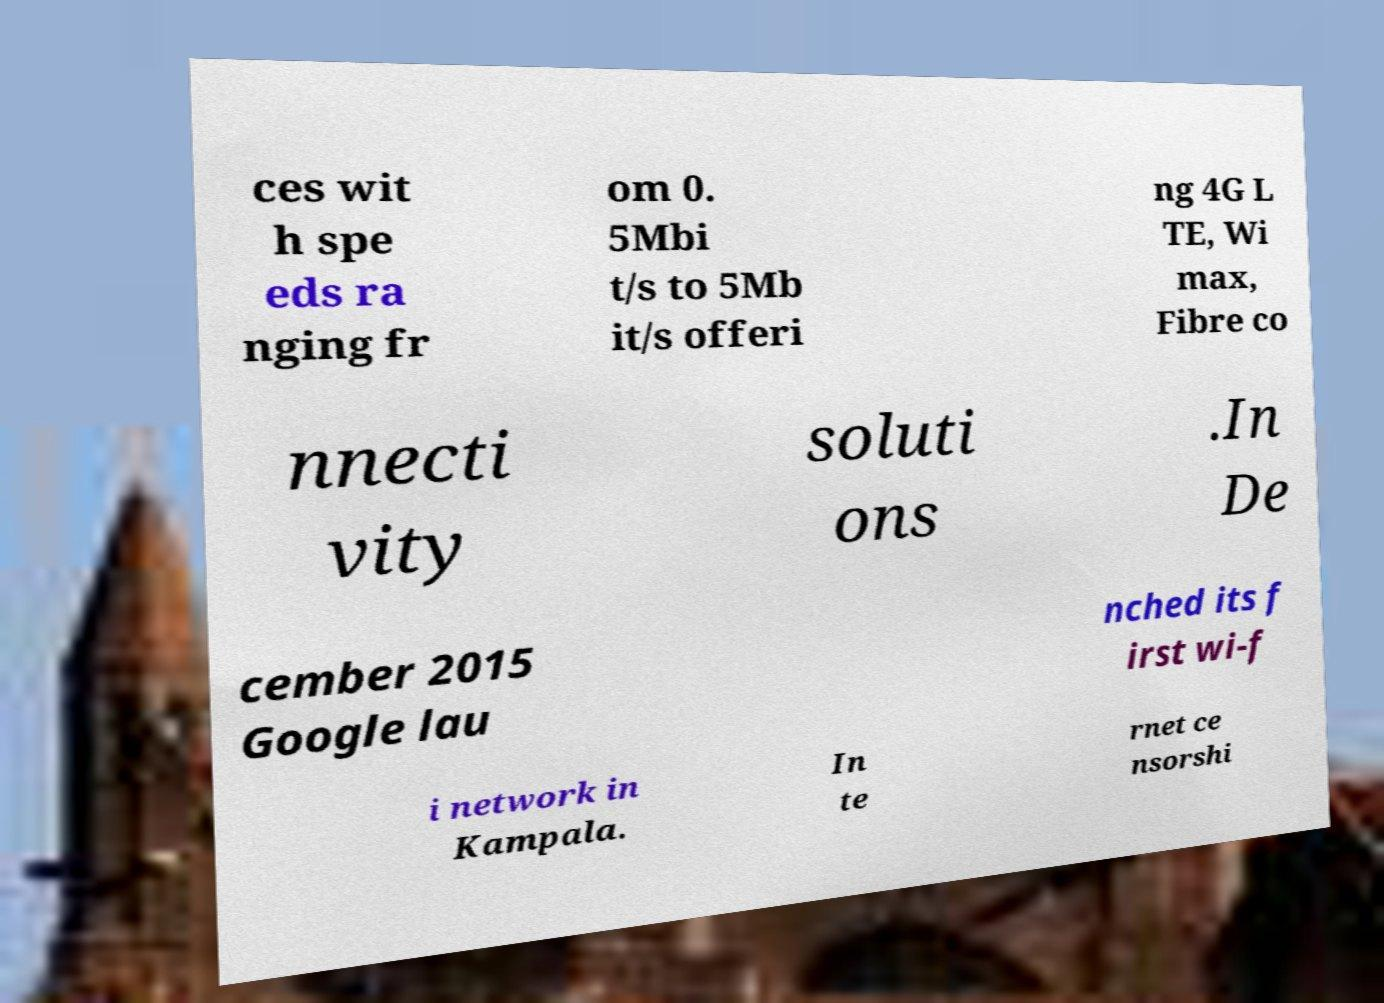Please read and relay the text visible in this image. What does it say? ces wit h spe eds ra nging fr om 0. 5Mbi t/s to 5Mb it/s offeri ng 4G L TE, Wi max, Fibre co nnecti vity soluti ons .In De cember 2015 Google lau nched its f irst wi-f i network in Kampala. In te rnet ce nsorshi 